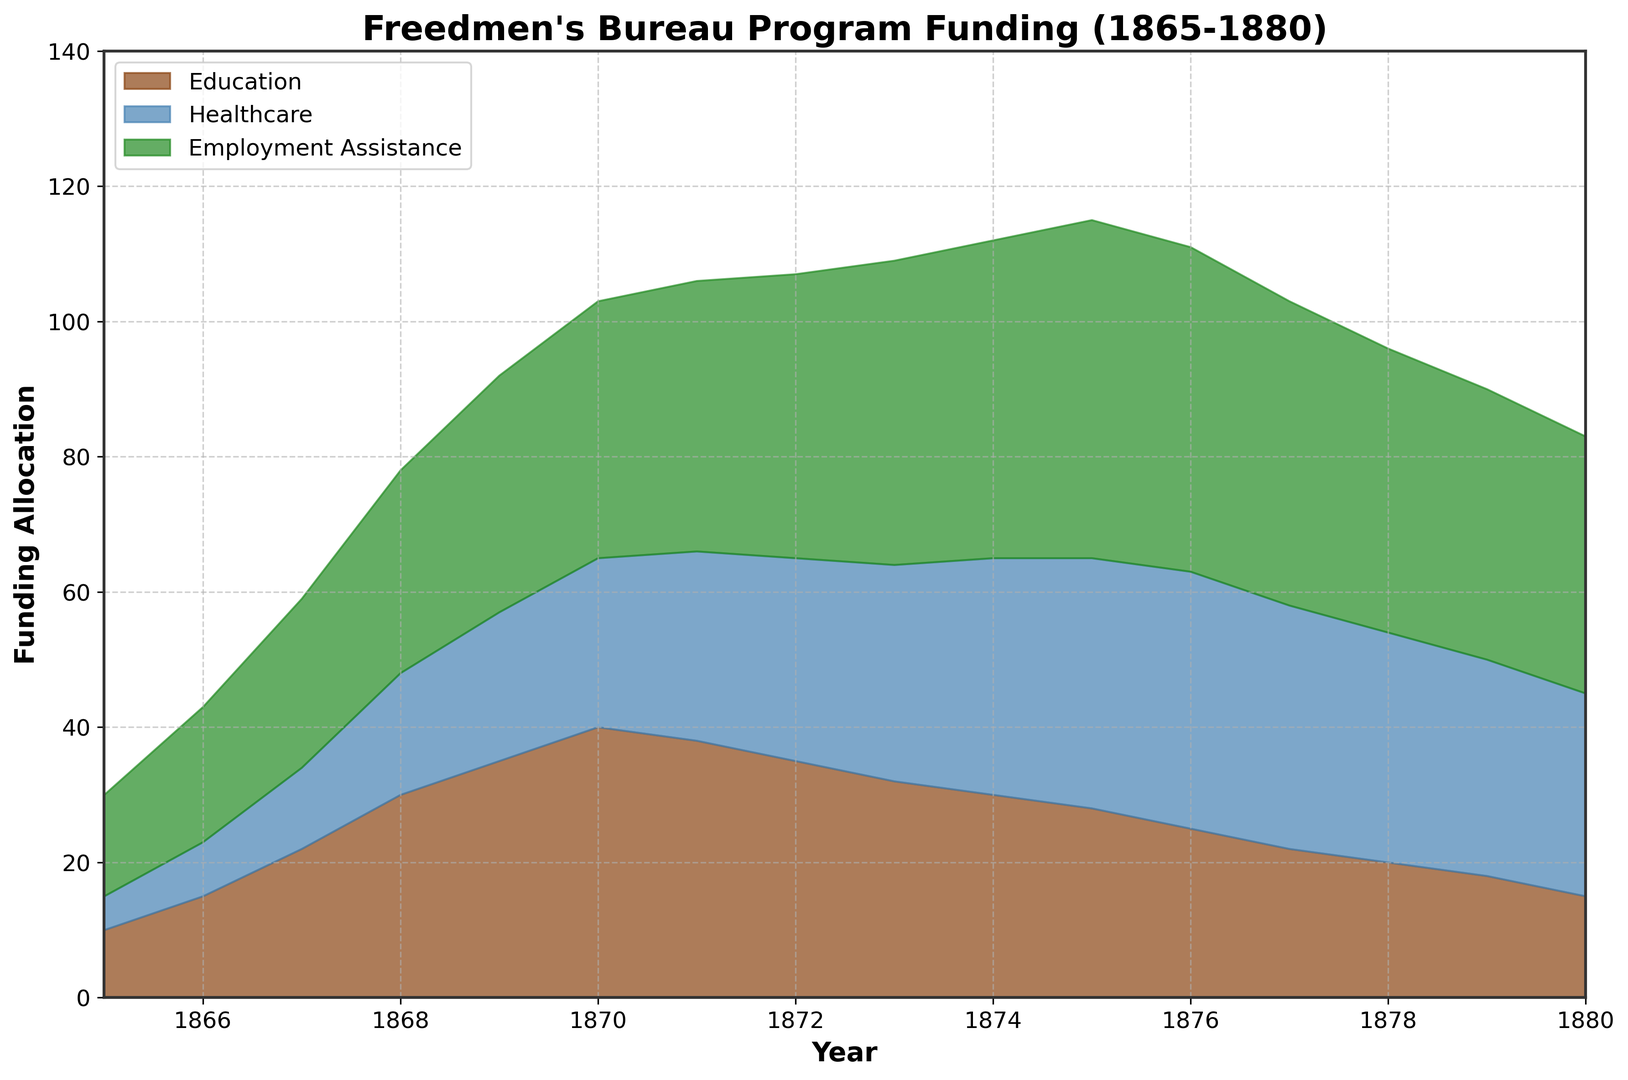What's the overall trend in funding allocation for the Education program from 1865 to 1880? To determine the trend, observe the general direction of the area's height representing Education over time. It starts at 10 in 1865 and peaks at 40 by 1870 but then gradually declines to 15 by 1880. The funding initially increases, reaches a peak around 1870, and then decreases towards the end of the period.
Answer: Initially increases, peaks around 1870, and then decreases Which program consistently received the highest funding from 1865 to 1880? Examine the heights of the areas representing each program. The highest segment is the combined height of all programs, but Employment Assistance is always at the top, indicating it received the highest funding throughout the years.
Answer: Employment Assistance How did the total funding allocation for all programs change from 1865 to 1880? Calculate total funding for any two given points, such as 1865 and 1880. In 1865, sum of Education (10), Healthcare (5), and Employment Assistance (15) is 30; in 1880, sum of Education (15), Healthcare (30), and Employment Assistance (38) is 83. Notice the overall increase from 30 to 83.
Answer: Increased During which year did Healthcare funding meet or exceed Employment Assistance funding for the first time? Healthcare (blue) surpassing Employment Assistance (green) means their combined height should match the height of Healthcare alone. The map shows that Healthcare never surpasses Employment Assistance in any year.
Answer: Never What is the difference in allocation between Healthcare and Education in 1874? For 1874, Healthcare is at 35 and Education is at 30. Subtract Education from Healthcare to get the difference: 35 - 30 = 5.
Answer: 5 What was the total funding allocation in 1869? Add the funding for all three programs in 1869: Education (35), Healthcare (22), and Employment Assistance (35). So, 35 + 22 + 35 = 92.
Answer: 92 What is the average funding for the Education program between 1865 and 1880? Sum up the funding for Education from 1865 to 1880 (10 + 15 + 22 + 30 + 35 + 40 + 38 + 35 + 32 + 30 + 28 + 25 + 22 + 20 + 18 + 15) = 415. There are 16 years, so divide the sum by 16: 415 / 16 = 25.9375.
Answer: 25.9375 In which year was the total funding allocation the highest? Observe the overall height (sum of all areas) represented visually. The year with the highest sum is 1875 with Education (28), Healthcare (37), and Employment Assistance (50). Total funding equals 115.
Answer: 1875 Which segment (Education, Healthcare, or Employment Assistance) had the smallest funding allocation percentage-wise in 1865? First, calculate the total funding in 1865: 10 (Education) + 5 (Healthcare) + 15 (Employment Assistance) = 30. Now, calculate the percentage of each program's budget of the total. Education: (10/30)*100 = 33.33%, Healthcare: (5/30)*100 = 16.67%, Employment Assistance: (15/30)*100 = 50%. Healthcare has the smallest percentage.
Answer: Healthcare What is the sum of funding allocations for Education in 1871 and Healthcare in 1880? Take the value for Education in 1871, which is 38, and Healthcare in 1880, which is 30. Now sum these values: 38 + 30 = 68.
Answer: 68 